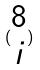<formula> <loc_0><loc_0><loc_500><loc_500>( \begin{matrix} 8 \\ i \end{matrix} )</formula> 